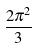Convert formula to latex. <formula><loc_0><loc_0><loc_500><loc_500>\frac { 2 \pi ^ { 2 } } { 3 }</formula> 